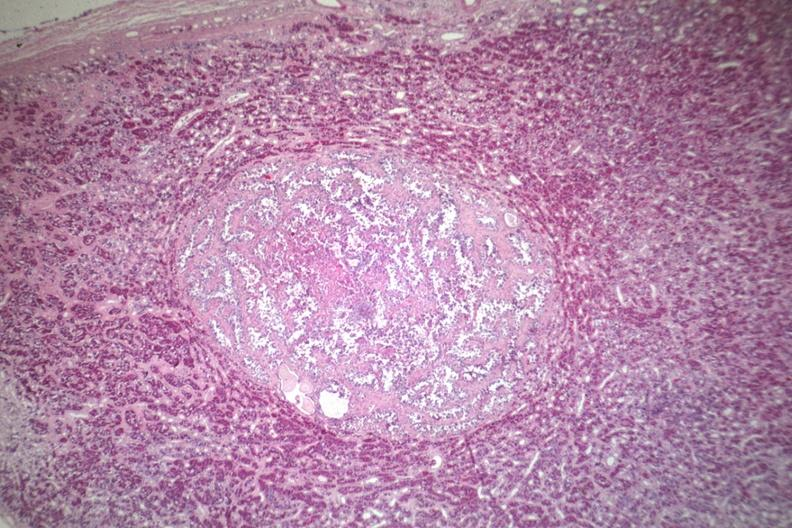what does well circumscribed papillary lesion see?
Answer the question using a single word or phrase. For high mag 